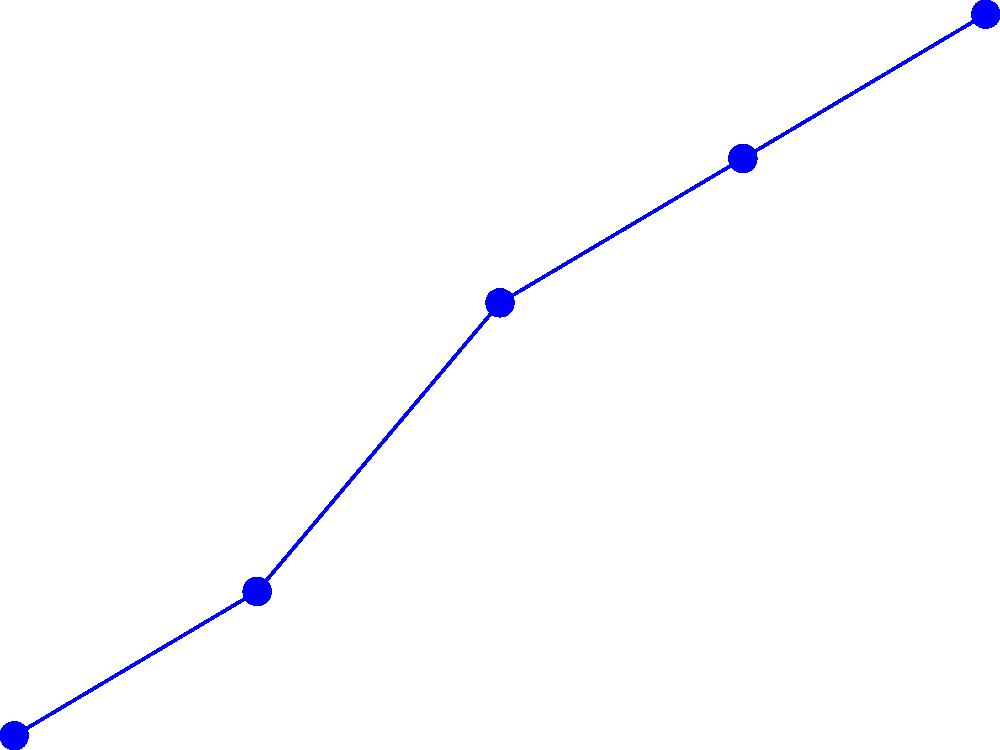Based on the line graph showing annual veterinary visit percentages for different pets from 2018 to 2022, which pet type experienced the highest percentage increase in vet visits over the 5-year period? To determine which pet type had the highest percentage increase in vet visits, we need to calculate the percentage change for each pet type from 2018 to 2022.

1. For dogs:
   Initial value (2018): 45%
   Final value (2022): 70%
   Percentage increase = $\frac{70 - 45}{45} \times 100 = 55.56\%$

2. For cats:
   Initial value (2018): 40%
   Final value (2022): 68%
   Percentage increase = $\frac{68 - 40}{40} \times 100 = 70\%$

3. For birds:
   Initial value (2018): 20%
   Final value (2022): 30%
   Percentage increase = $\frac{30 - 20}{20} \times 100 = 50\%$

Comparing these percentages, we can see that cats had the highest percentage increase at 70%.
Answer: Cats 